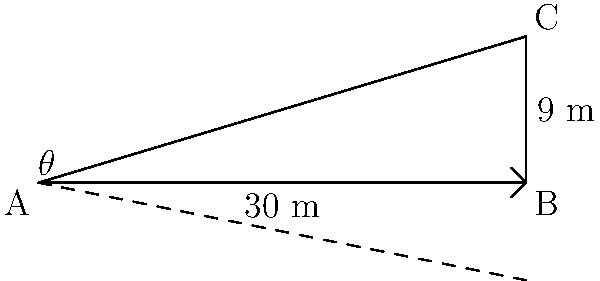As an organic farmer concerned with erosion control, you're measuring the slope of a hillside field. The field is represented by a right-angled triangle ABC, where AB is 30 meters long (the horizontal distance) and BC is 9 meters high (the vertical rise). What is the angle of slope ($\theta$) in degrees, rounded to the nearest whole number? To solve this problem, we'll use trigonometry, specifically the tangent function. Here's a step-by-step explanation:

1) In a right-angled triangle, the tangent of an angle is the ratio of the opposite side to the adjacent side.

2) In this case:
   - The opposite side (vertical rise) is 9 meters
   - The adjacent side (horizontal distance) is 30 meters

3) We can express this as:

   $\tan(\theta) = \frac{\text{opposite}}{\text{adjacent}} = \frac{9}{30} = 0.3$

4) To find the angle $\theta$, we need to use the inverse tangent function (arctan or $\tan^{-1}$):

   $\theta = \tan^{-1}(0.3)$

5) Using a calculator or trigonometric tables:

   $\theta \approx 16.7°$

6) Rounding to the nearest whole number:

   $\theta \approx 17°$

This angle represents the slope of the field, which is crucial information for implementing erosion control measures in sustainable agriculture.
Answer: $17°$ 